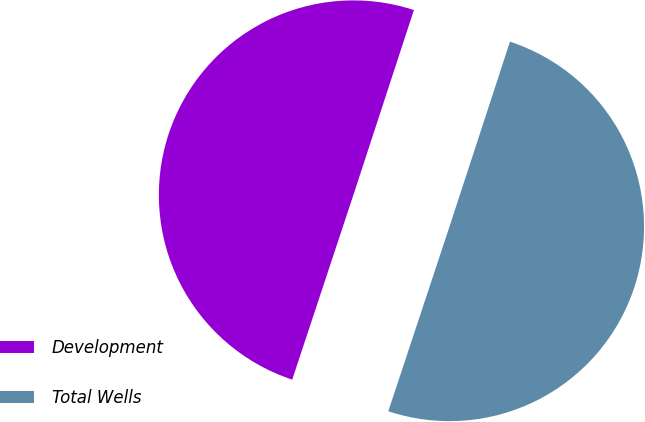Convert chart to OTSL. <chart><loc_0><loc_0><loc_500><loc_500><pie_chart><fcel>Development<fcel>Total Wells<nl><fcel>49.94%<fcel>50.06%<nl></chart> 